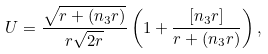<formula> <loc_0><loc_0><loc_500><loc_500>U = \frac { \sqrt { r + ( n _ { 3 } r ) } } { r \sqrt { 2 r } } \left ( 1 + \frac { [ n _ { 3 } r ] } { r + ( n _ { 3 } r ) } \right ) ,</formula> 